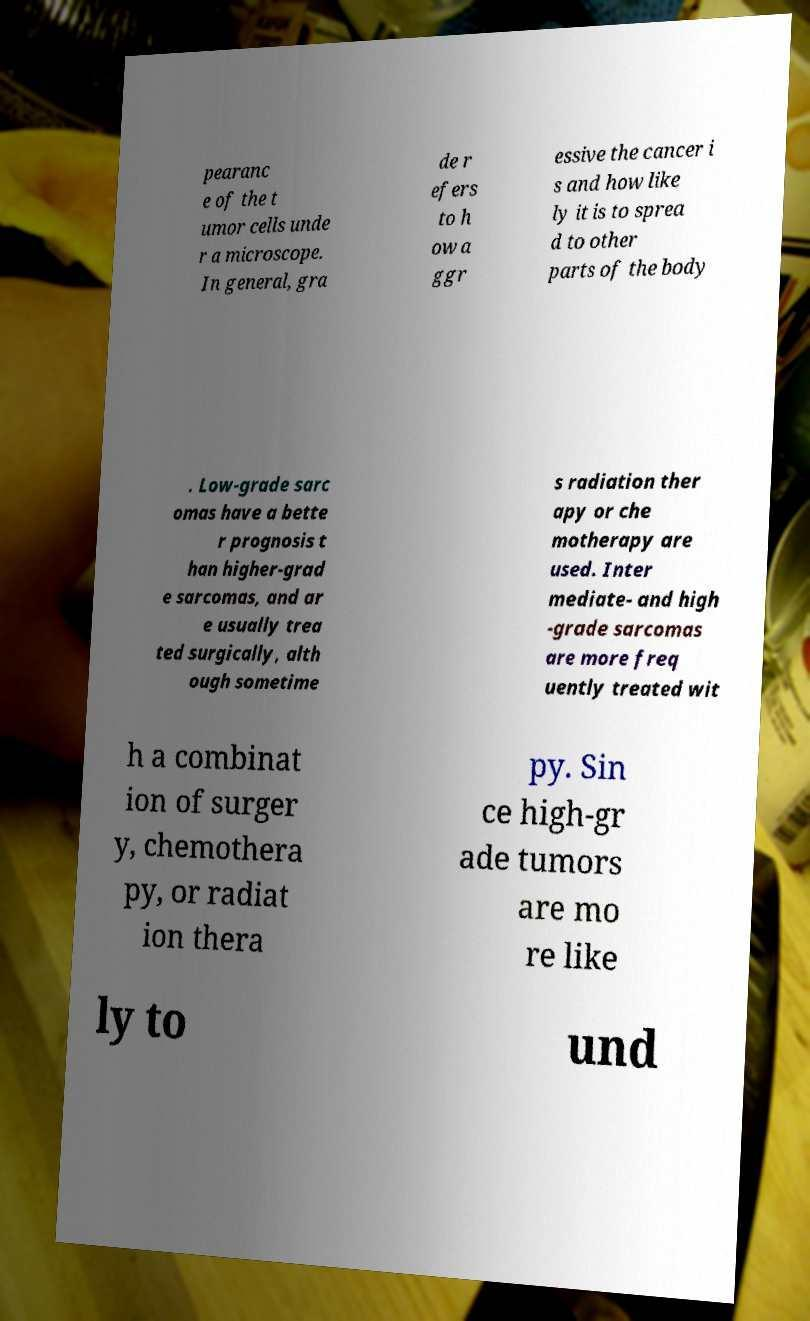Can you accurately transcribe the text from the provided image for me? pearanc e of the t umor cells unde r a microscope. In general, gra de r efers to h ow a ggr essive the cancer i s and how like ly it is to sprea d to other parts of the body . Low-grade sarc omas have a bette r prognosis t han higher-grad e sarcomas, and ar e usually trea ted surgically, alth ough sometime s radiation ther apy or che motherapy are used. Inter mediate- and high -grade sarcomas are more freq uently treated wit h a combinat ion of surger y, chemothera py, or radiat ion thera py. Sin ce high-gr ade tumors are mo re like ly to und 